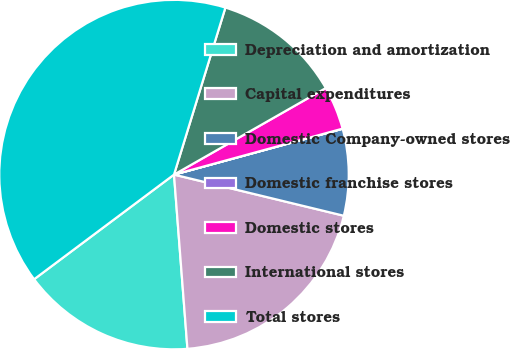Convert chart. <chart><loc_0><loc_0><loc_500><loc_500><pie_chart><fcel>Depreciation and amortization<fcel>Capital expenditures<fcel>Domestic Company-owned stores<fcel>Domestic franchise stores<fcel>Domestic stores<fcel>International stores<fcel>Total stores<nl><fcel>16.0%<fcel>19.99%<fcel>8.01%<fcel>0.01%<fcel>4.01%<fcel>12.0%<fcel>39.97%<nl></chart> 